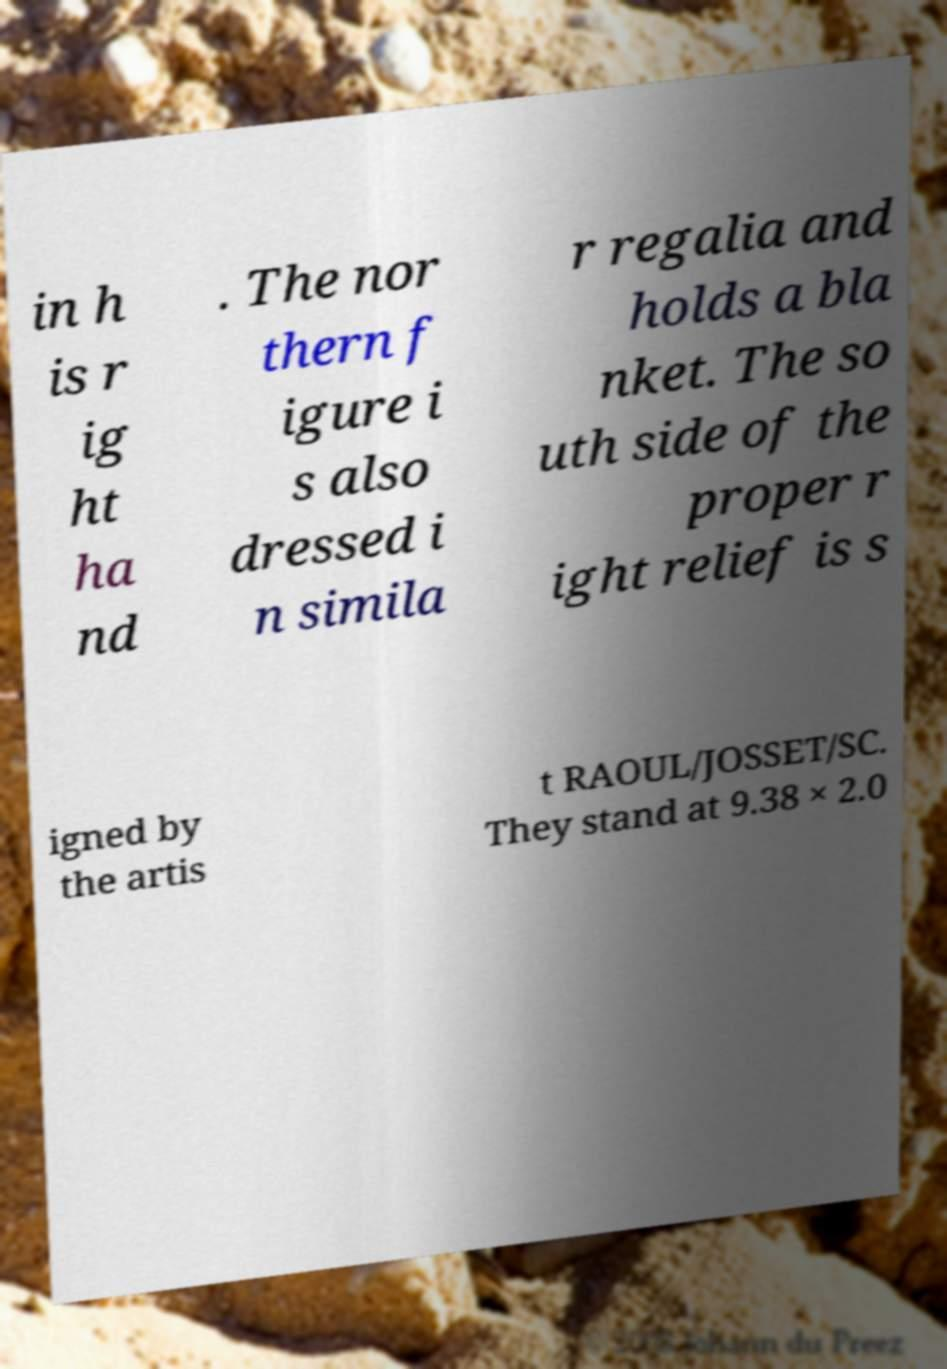What messages or text are displayed in this image? I need them in a readable, typed format. in h is r ig ht ha nd . The nor thern f igure i s also dressed i n simila r regalia and holds a bla nket. The so uth side of the proper r ight relief is s igned by the artis t RAOUL/JOSSET/SC. They stand at 9.38 × 2.0 